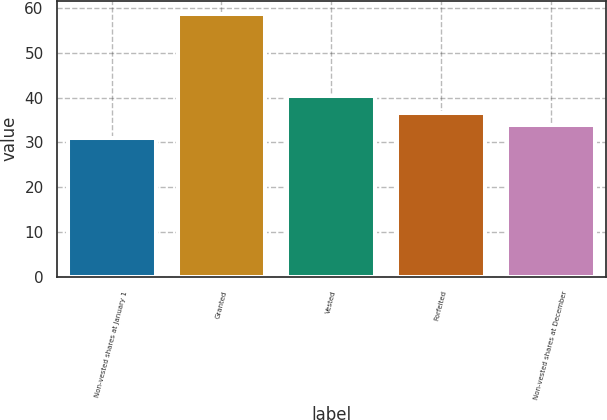Convert chart. <chart><loc_0><loc_0><loc_500><loc_500><bar_chart><fcel>Non-vested shares at January 1<fcel>Granted<fcel>Vested<fcel>Forfeited<fcel>Non-vested shares at December<nl><fcel>31.08<fcel>58.68<fcel>40.36<fcel>36.6<fcel>33.84<nl></chart> 